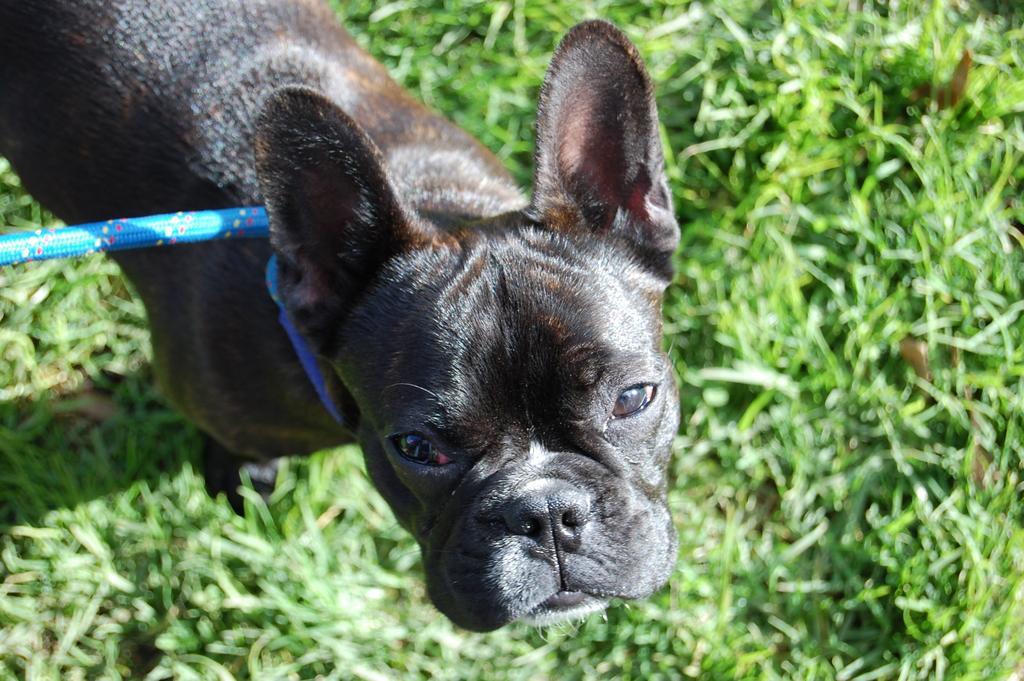How would you summarize this image in a sentence or two? In this image we can see a dog with a lease on the grass. 